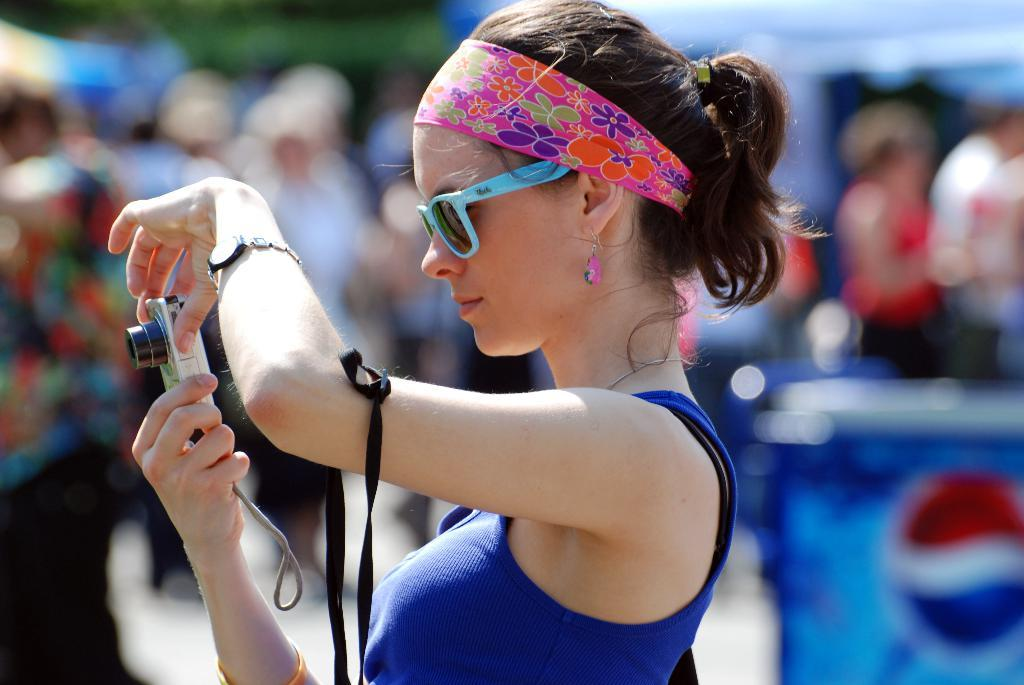Who is the main subject in the image? There is a girl in the image. What is the girl wearing on her head? The girl is wearing a headband. What type of eyewear is the girl wearing? The girl is wearing sunglasses. What object is the girl holding in her hand? The girl is holding a camera in her hand. How would you describe the background of the image? The background of the image is blurry. What type of scarecrow can be seen in the background of the image? There is no scarecrow present in the image. How does the coastline look in the image? There is no coastline visible in the image. 